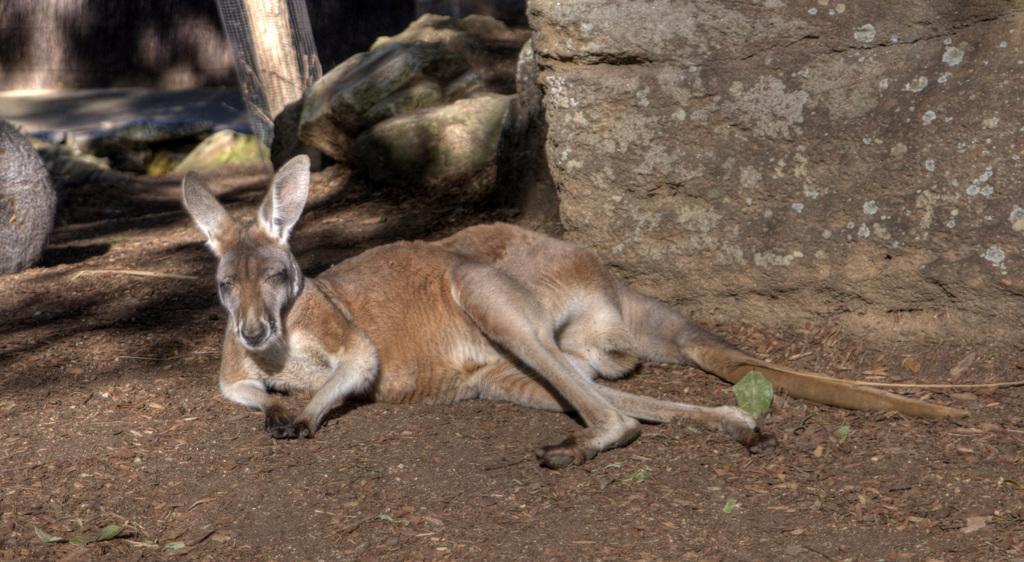How would you summarize this image in a sentence or two? In this image we can see a kangaroo. In the back there are rocks. 